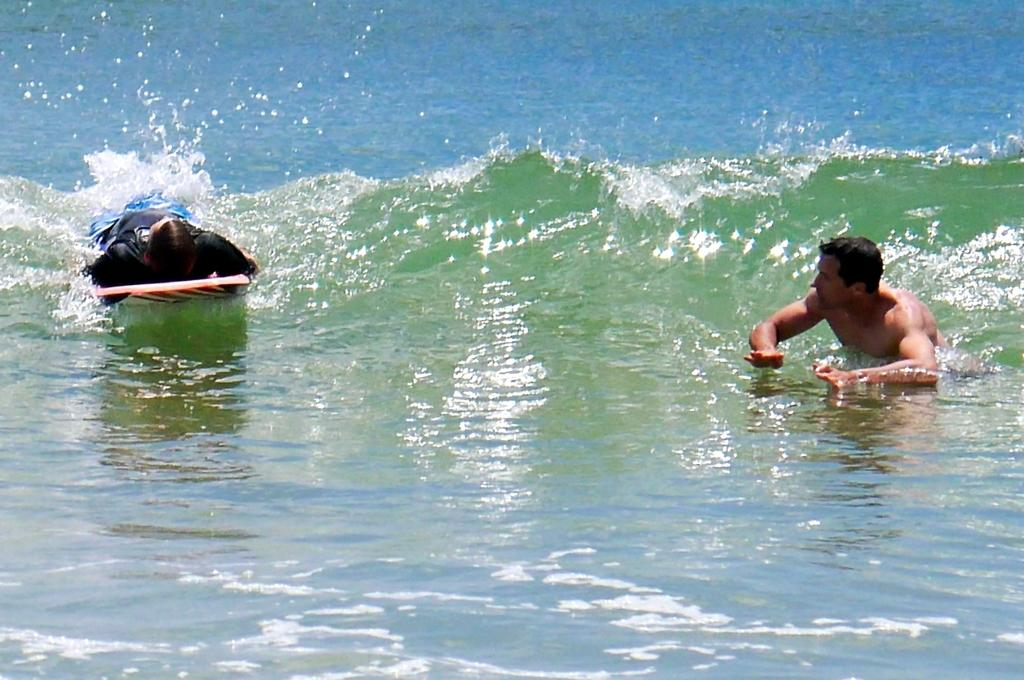How many people are in the image? There are two persons in the image. What are the two persons doing in the image? The two persons are swimming. Where are the two persons swimming? The location of the swimming is a sea. How does the sea control the copy of the book in the image? There is no book or copy mentioned in the image; it only features two persons swimming in a sea. 